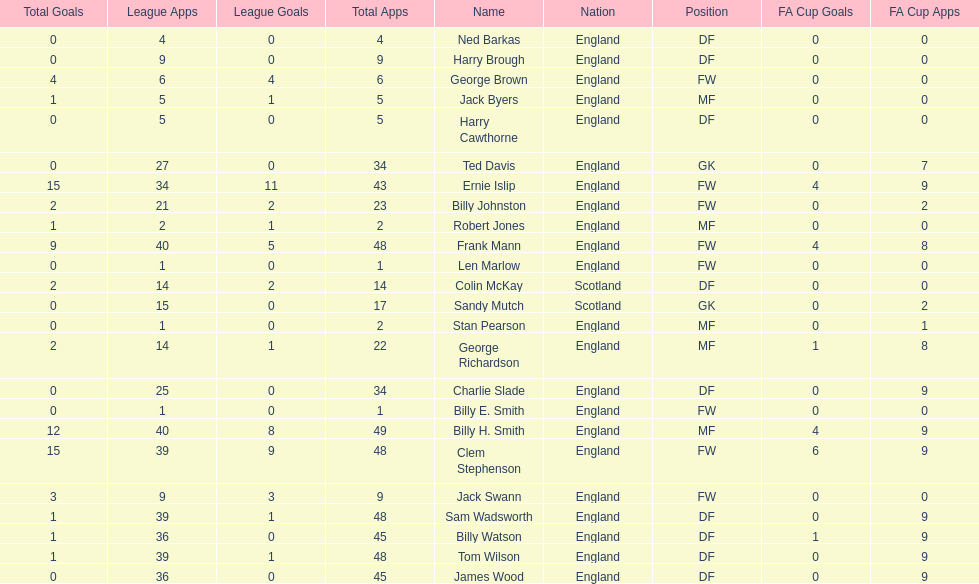What are the number of league apps ted davis has? 27. 